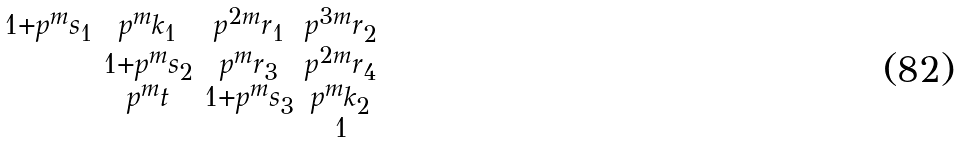<formula> <loc_0><loc_0><loc_500><loc_500>\begin{smallmatrix} 1 + p ^ { m } s _ { 1 } & p ^ { m } k _ { 1 } & p ^ { 2 m } r _ { 1 } & p ^ { 3 m } r _ { 2 } \\ & 1 + p ^ { m } s _ { 2 } & p ^ { m } r _ { 3 } & p ^ { 2 m } r _ { 4 } \\ & p ^ { m } t & 1 + p ^ { m } s _ { 3 } & p ^ { m } k _ { 2 } \\ & & & 1 \end{smallmatrix}</formula> 